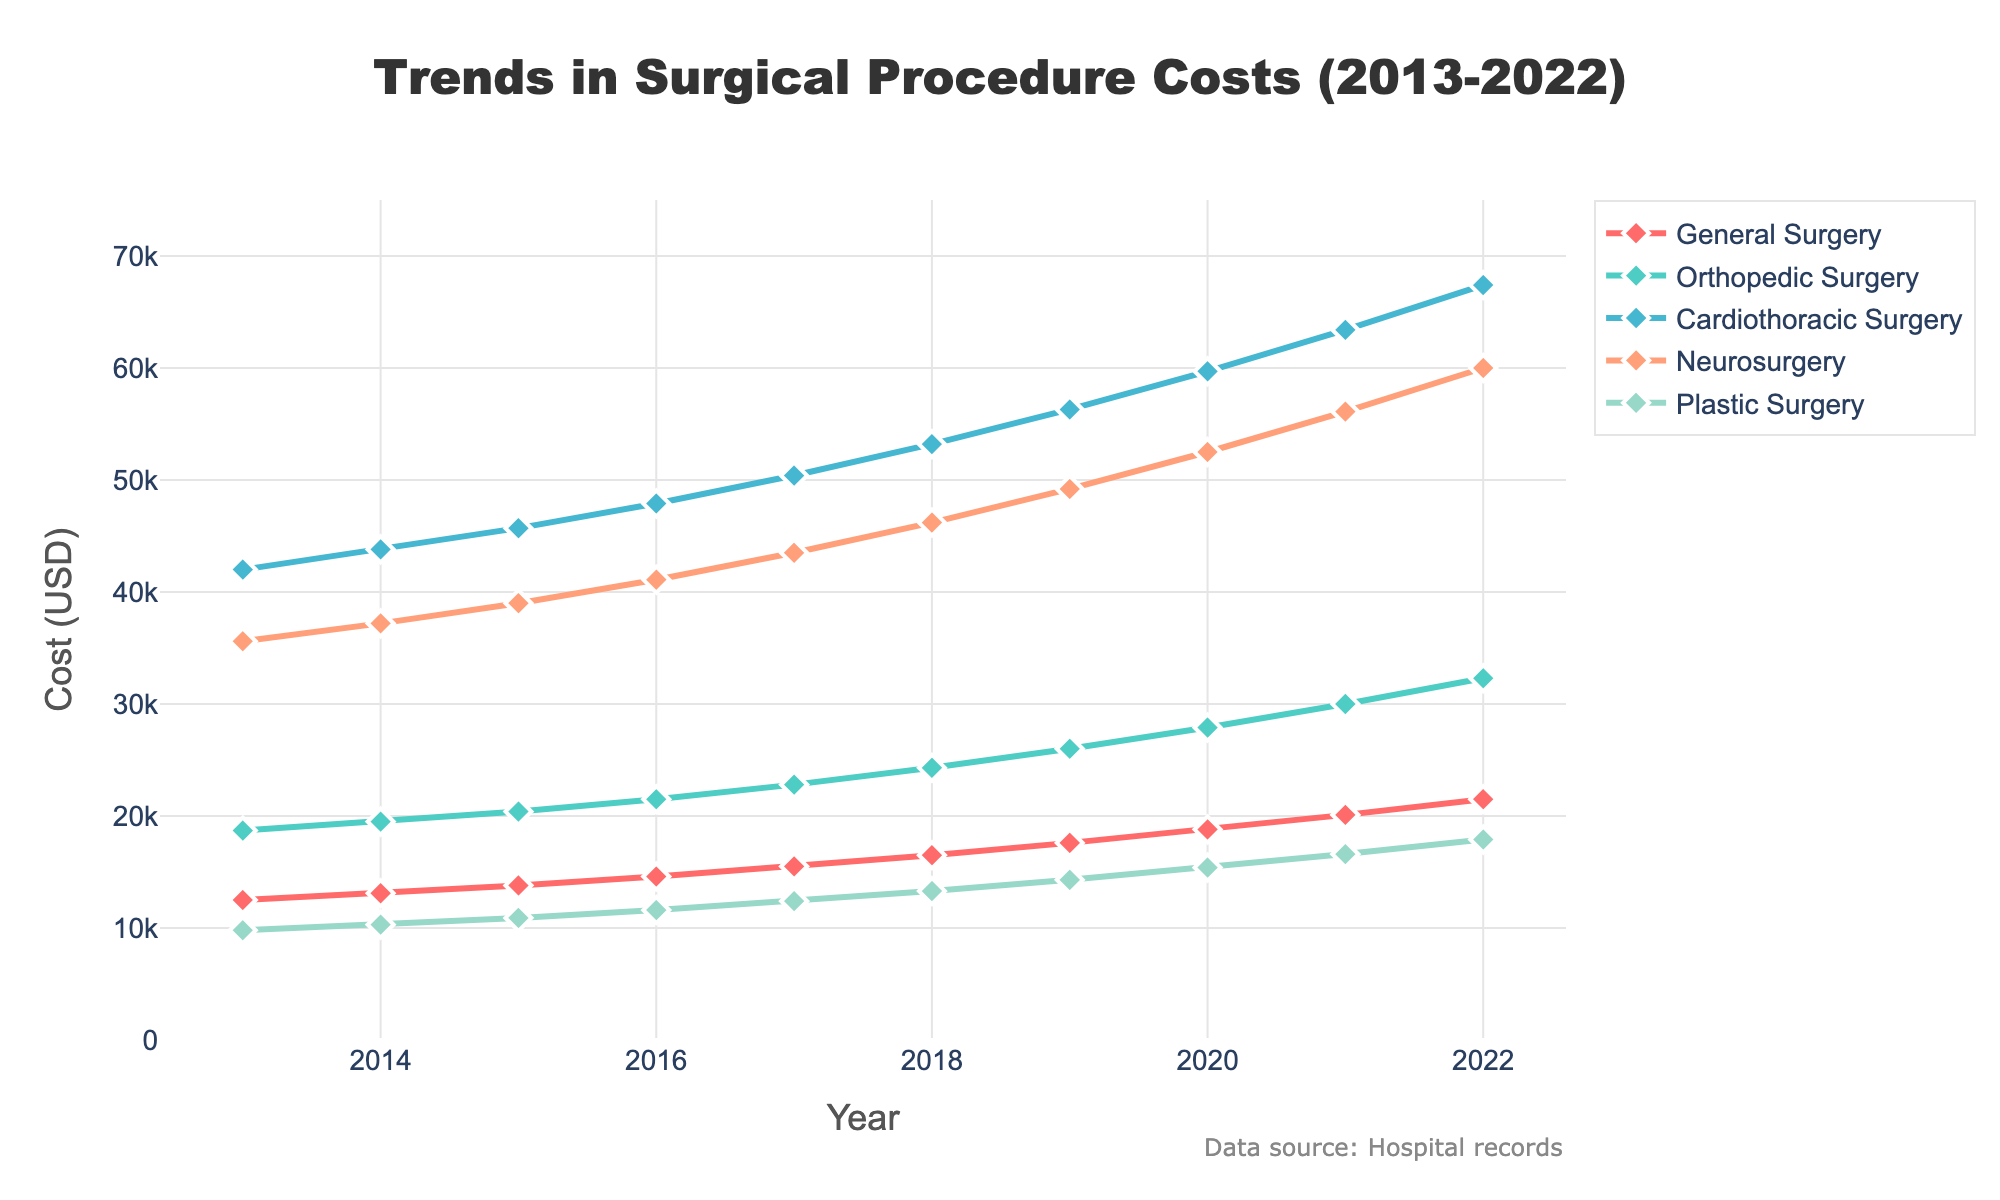What was the cost of Neurosurgery in 2019? To answer this, look for the line representing Neurosurgery on the chart and find the corresponding data point for the year 2019. Neurosurgery costs $49,200 in 2019.
Answer: 49,200 Which specialty saw the highest increase in costs over the decade? Identify the start and end costs for each specialty from the figure and calculate the difference. The highest increase can be observed in Cardiothoracic Surgery, which increased from $42,000 in 2013 to $67,400 in 2022.
Answer: Cardiothoracic Surgery What is the average cost of Plastic Surgery from 2013 to 2022? Sum the costs of Plastic Surgery for each year from the figure and then divide by the number of years. The average is (9800 + 10300 + 10900 + 11600 + 12400 + 13300 + 14300 + 15400 + 16600 + 17900)/10 = 13250.
Answer: 13,250 By how much did Orthopedic Surgery costs increase from 2017 to 2020? Look at the costs for Orthopedic Surgery in 2017 and 2020. Subtract the 2017 cost from the 2020 cost: 27900 - 22800 = 5100.
Answer: 5,100 Is there any year when the costs of General Surgery were equal to Plastic Surgery? Compare the General Surgery and Plastic Surgery cost lines year by year on the figure to see if there is any overlap. There isn't a year where the costs are equal.
Answer: No Which specialty shows the steadiest increase in costs over the decade? Identify which specialty's line on the chart shows the smoothest upward trend without sharp fluctuations. General Surgery shows a steady and consistent increase.
Answer: General Surgery What is the percentage increase in Cardiothoracic Surgery costs from 2013 to 2022? Calculate the percentage increase as ((End Value - Start Value) / Start Value) * 100. For Cardiothoracic Surgery, the increase is ((67400 - 42000) / 42000) * 100 = 60.48%.
Answer: 60.48% In which year did Neurosurgery costs surpass $50,000? Look at the Neurosurgery line on the chart and identify the first year when the value crosses $50,000. This happens in 2018.
Answer: 2018 Between General and Orthopedic Surgery, which specialty had a higher cost in 2015? Compare the data points for General Surgery and Orthopedic Surgery in 2015 on the figure. Orthopedic Surgery had a higher cost at $20,400.
Answer: Orthopedic Surgery 